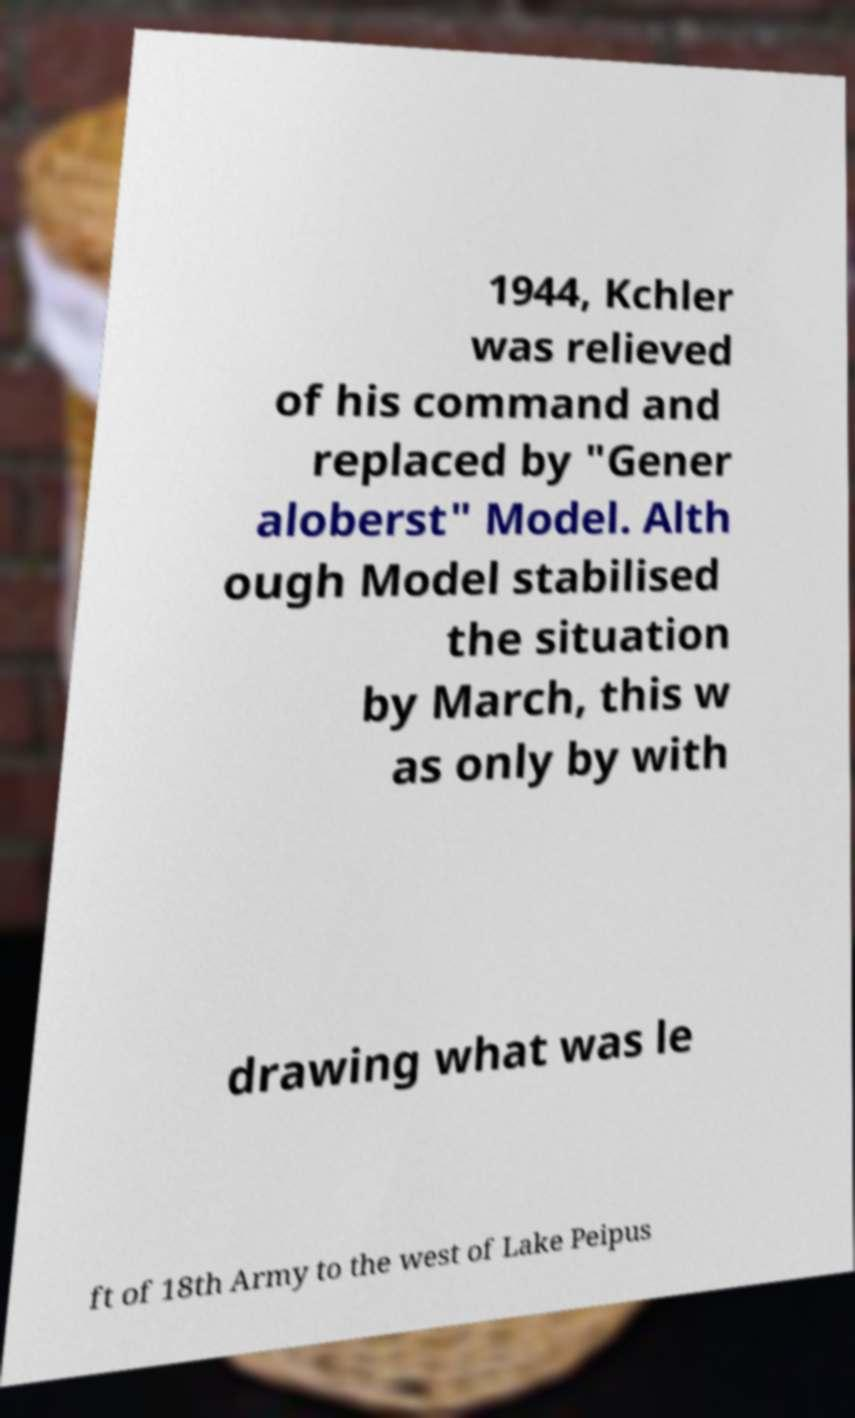What messages or text are displayed in this image? I need them in a readable, typed format. 1944, Kchler was relieved of his command and replaced by "Gener aloberst" Model. Alth ough Model stabilised the situation by March, this w as only by with drawing what was le ft of 18th Army to the west of Lake Peipus 